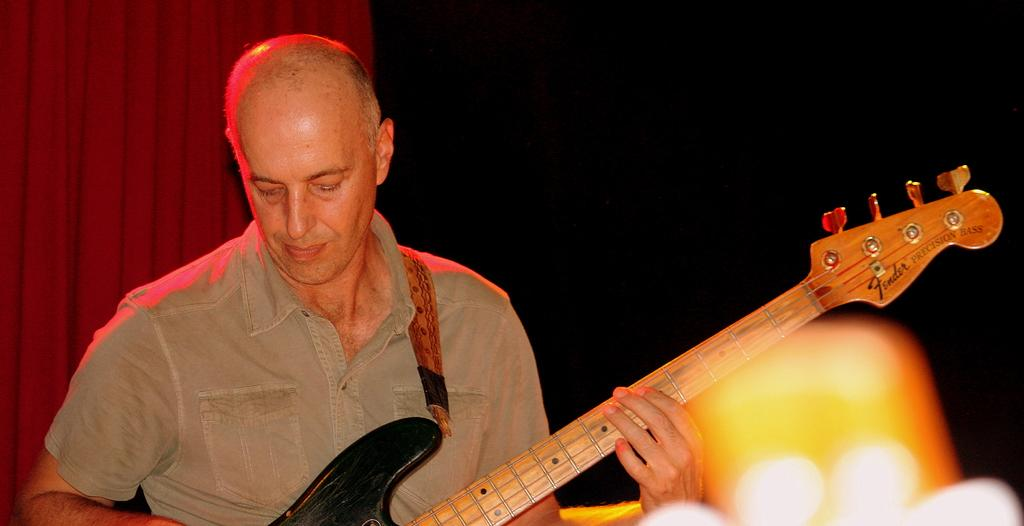Who is the person in the image? There is a man in the image. What is the man holding in the image? The man is holding a guitar. What is the man doing with the guitar? The man is playing the guitar. What can be seen in the background of the image? There is a red color curtain in the background of the image. Can you tell me how many times the man's mother sneezed while he was playing the guitar? There is no information about the man's mother or any sneezing in the image, so it cannot be determined. 